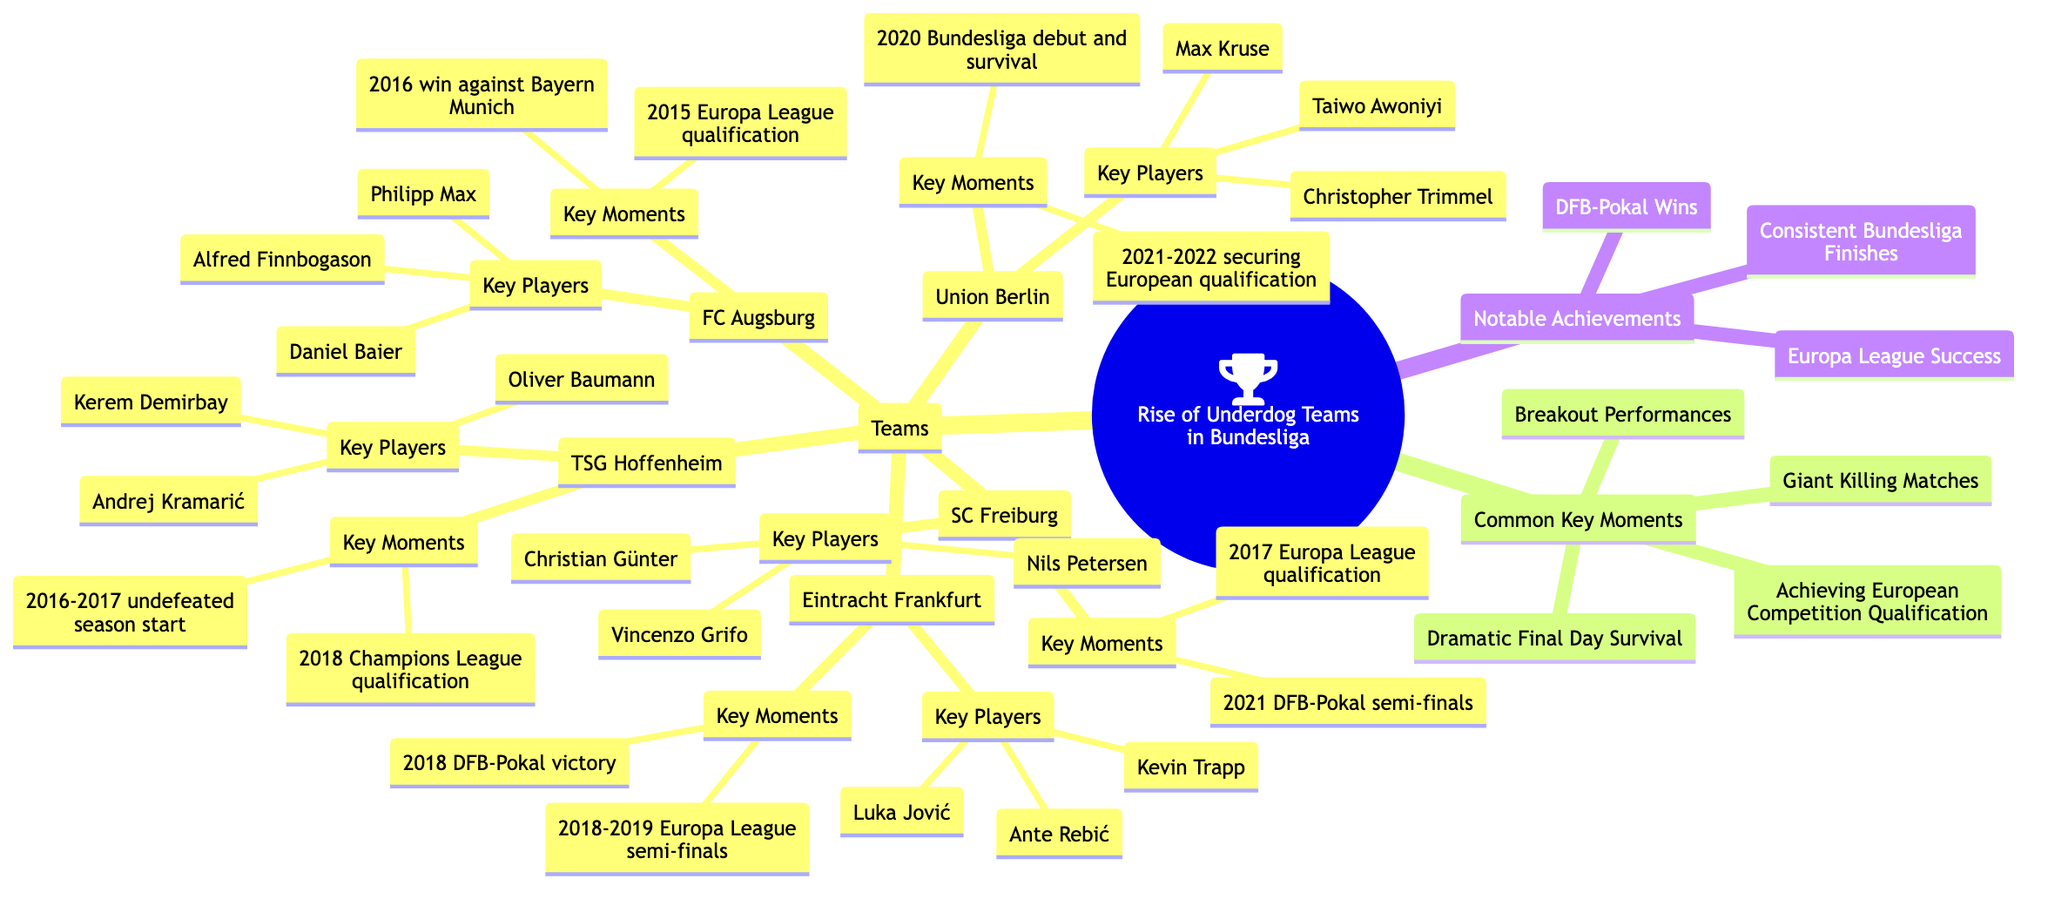What teams are included in the concept map? The diagram lists five teams: Eintracht Frankfurt, TSG Hoffenheim, SC Freiburg, Union Berlin, and FC Augsburg. These teams are all under the main topic of the rise of underdog teams in the Bundesliga, as specified in the 'Teams' section of the diagram.
Answer: Eintracht Frankfurt, TSG Hoffenheim, SC Freiburg, Union Berlin, FC Augsburg How many key players does SC Freiburg have? In the section for SC Freiburg, there are three key players listed: Christian Günter, Vincenzo Grifo, and Nils Petersen. Therefore, counting these players gives the total of three.
Answer: 3 Which team achieved European competition qualification in 2021-2022? The diagram states that Union Berlin secured European qualification in the 2021-2022 season, as noted in their key moments. This specific achievement is clearly represented under the Union Berlin section.
Answer: Union Berlin What notable achievement is shared by Eintracht Frankfurt and TSG Hoffenheim? Both Eintracht Frankfurt and TSG Hoffenheim share the notable achievement of "Europa League Success." This is indicated in the 'Notable Achievements' section of the concept map, showing that multiple teams have reached a level of success in this competition.
Answer: Europa League Success Which player is associated with FC Augsburg? The key players for FC Augsburg listed in the diagram are Daniel Baier, Alfred Finnbogason, and Philipp Max. Any of these names could be the answer, but selecting any one of them is appropriate based on the provided information.
Answer: Daniel Baier How many common key moments are mentioned in the diagram? The diagram specifies four common key moments: Dramatic Final Day Survival, Giant Killing Matches, Breakout Performances, and Achieving European Competition Qualification. By simply counting these entries, the total number is determined.
Answer: 4 What is a key moment for TSG Hoffenheim? The diagram indicates two key moments for TSG Hoffenheim: "2016-2017 undefeated season start" and "2018 Champions League qualification." Both of these are significant moments highlighting Hoffenheim's progress in Bundesliga history.
Answer: 2016-2017 undefeated season start Which team won the DFB-Pokal in 2018? According to the key moments of Eintracht Frankfurt, they had a victory in the DFB-Pokal in 2018, showcasing a significant achievement for the team. This win is specifically included in the moments listed for Frankfurt.
Answer: Eintracht Frankfurt 